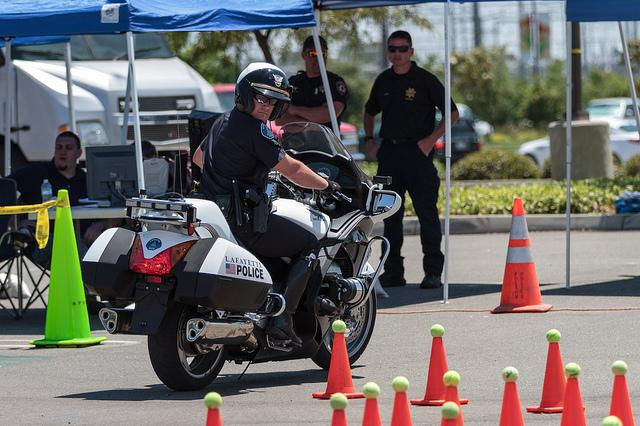What locale does the policeman serve?

Choices:
A) bloomington
B) lafayette
C) shreveport
D) monroe lafayette 